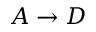Convert formula to latex. <formula><loc_0><loc_0><loc_500><loc_500>A \rightarrow D</formula> 